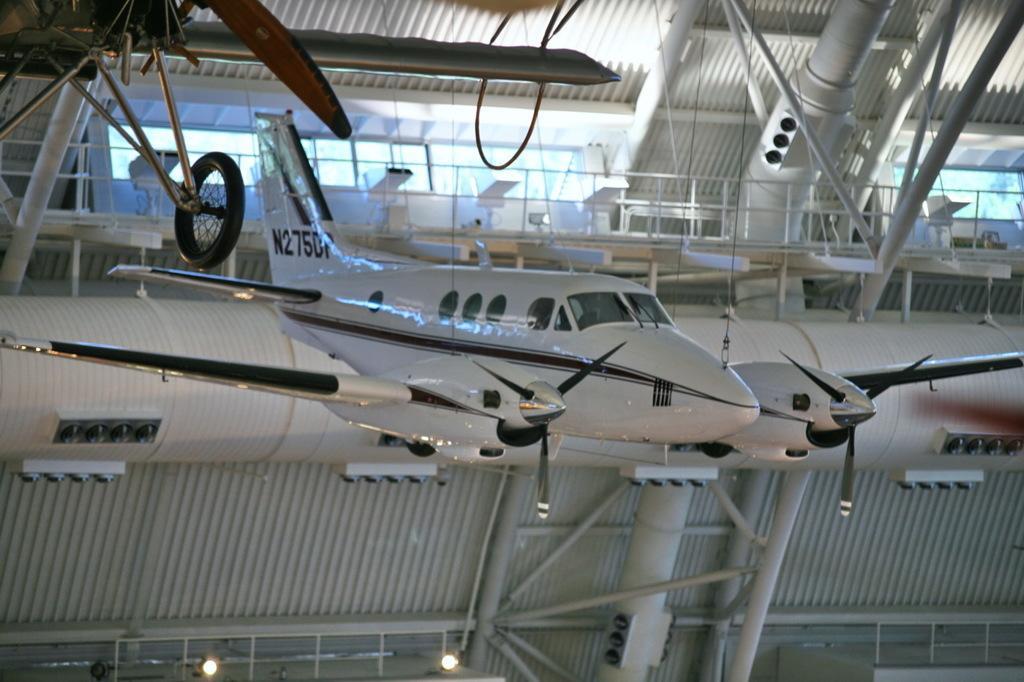Can you describe this image briefly? In this image there are planes, shed, lights, rods, railing, windows and objects.   